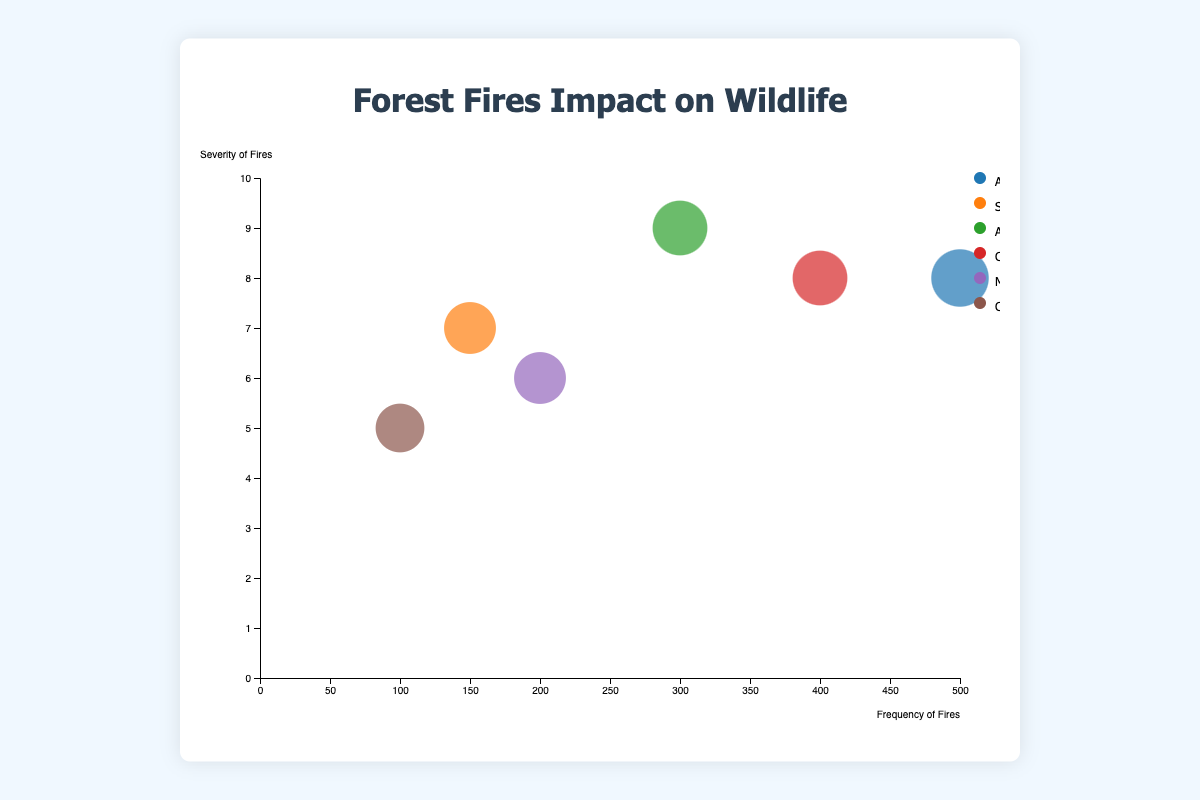What's the title of the chart? The title of the chart is displayed at the top and reads "Forest Fires Impact on Wildlife".
Answer: Forest Fires Impact on Wildlife What does the size of each bubble represent? The size of each bubble is determined by the "Impact_on_Wildlife" metric. Larger bubbles indicate a higher impact on native wildlife populations.
Answer: Impact on native wildlife populations Which region has the highest frequency of fires? By looking at the x-axis, which represents the frequency of fires, the "Amazon Rainforest" region has the highest frequency with a value of 500.
Answer: Amazon Rainforest Which two regions have the same severity of fires? The severity of fires is shown on the y-axis. Both "Amazon Rainforest" and "California Forests" have a severity rating of 8.
Answer: Amazon Rainforest and California Forests Compare the impact on wildlife between the "Amazon Rainforest" and the "Congo Rainforest". The size of the bubbles indicates the impact on wildlife. The "Amazon Rainforest" has a larger bubble (9) compared to the "Congo Rainforest" (6), indicating a greater impact on wildlife.
Answer: Amazon Rainforest has a greater impact Which region has the lowest severity of fires? By checking the y-axis, the "Congo Rainforest" has the lowest severity of fires with a value of 5.
Answer: Congo Rainforest How many regions are represented in the chart? Each unique color on the chart represents a different region. There are six distinct regions displayed.
Answer: 6 Is there a correlation between the frequency and severity of fires? Observing the placement of bubbles, there appears to be a moderate correlation as regions with higher frequency tend to have higher severity, though not perfectly linear.
Answer: Moderate positive correlation If a region has a higher frequency of fires, does it always result in a higher impact on wildlife? Assessing the bubbles, a higher frequency does not always correlate with a higher impact. For example, the "Amazon Rainforest" has a high impact, but "California Forests" with a similar frequency have a slightly lower impact (8).
Answer: No, not always Which region has the highest impact on native wildlife populations and what is that impact score? By looking at the size of the bubbles and the "Impact_on_Wildlife" metric displayed in the tooltip, the "Amazon Rainforest" has the highest impact with a score of 9.
Answer: Amazon Rainforest, 9 